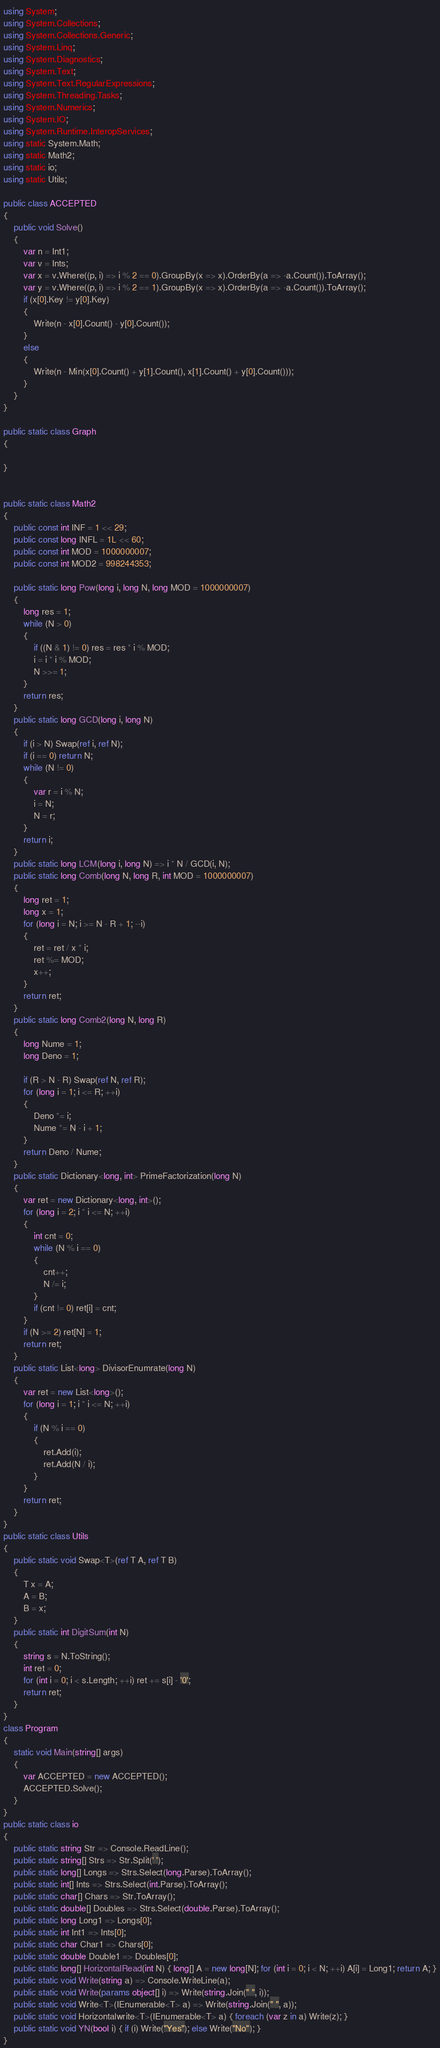Convert code to text. <code><loc_0><loc_0><loc_500><loc_500><_C#_>using System;
using System.Collections;
using System.Collections.Generic;
using System.Linq;
using System.Diagnostics;
using System.Text;
using System.Text.RegularExpressions;
using System.Threading.Tasks;
using System.Numerics;
using System.IO;
using System.Runtime.InteropServices;
using static System.Math;
using static Math2;
using static io;
using static Utils;

public class ACCEPTED
{
    public void Solve()
    {
        var n = Int1;
        var v = Ints;
        var x = v.Where((p, i) => i % 2 == 0).GroupBy(x => x).OrderBy(a => -a.Count()).ToArray();
        var y = v.Where((p, i) => i % 2 == 1).GroupBy(x => x).OrderBy(a => -a.Count()).ToArray();
        if (x[0].Key != y[0].Key)
        {
            Write(n - x[0].Count() - y[0].Count());
        }
        else
        {
            Write(n - Min(x[0].Count() + y[1].Count(), x[1].Count() + y[0].Count()));
        }
    }
}

public static class Graph
{

}


public static class Math2
{
    public const int INF = 1 << 29;
    public const long INFL = 1L << 60;
    public const int MOD = 1000000007;
    public const int MOD2 = 998244353;

    public static long Pow(long i, long N, long MOD = 1000000007)
    {
        long res = 1;
        while (N > 0)
        {
            if ((N & 1) != 0) res = res * i % MOD;
            i = i * i % MOD;
            N >>= 1;
        }
        return res;
    }
    public static long GCD(long i, long N)
    {
        if (i > N) Swap(ref i, ref N);
        if (i == 0) return N;
        while (N != 0)
        {
            var r = i % N;
            i = N;
            N = r;
        }
        return i;
    }
    public static long LCM(long i, long N) => i * N / GCD(i, N);
    public static long Comb(long N, long R, int MOD = 1000000007)
    {
        long ret = 1;
        long x = 1;
        for (long i = N; i >= N - R + 1; --i)
        {
            ret = ret / x * i;
            ret %= MOD;
            x++;
        }
        return ret;
    }
    public static long Comb2(long N, long R)
    {
        long Nume = 1;
        long Deno = 1;

        if (R > N - R) Swap(ref N, ref R);
        for (long i = 1; i <= R; ++i)
        {
            Deno *= i;
            Nume *= N - i + 1;
        }
        return Deno / Nume;
    }
    public static Dictionary<long, int> PrimeFactorization(long N)
    {
        var ret = new Dictionary<long, int>();
        for (long i = 2; i * i <= N; ++i)
        {
            int cnt = 0;
            while (N % i == 0)
            {
                cnt++;
                N /= i;
            }
            if (cnt != 0) ret[i] = cnt;
        }
        if (N >= 2) ret[N] = 1;
        return ret;
    }
    public static List<long> DivisorEnumrate(long N)
    {
        var ret = new List<long>();
        for (long i = 1; i * i <= N; ++i)
        {
            if (N % i == 0)
            {
                ret.Add(i);
                ret.Add(N / i);
            }
        }
        return ret;
    }
}
public static class Utils
{
    public static void Swap<T>(ref T A, ref T B)
    {
        T x = A;
        A = B;
        B = x;
    }
    public static int DigitSum(int N)
    {
        string s = N.ToString();
        int ret = 0;
        for (int i = 0; i < s.Length; ++i) ret += s[i] - '0';
        return ret;
    }
}
class Program
{
    static void Main(string[] args)
    {
        var ACCEPTED = new ACCEPTED();
        ACCEPTED.Solve();
    }
}
public static class io
{
    public static string Str => Console.ReadLine();
    public static string[] Strs => Str.Split(' ');
    public static long[] Longs => Strs.Select(long.Parse).ToArray();
    public static int[] Ints => Strs.Select(int.Parse).ToArray();
    public static char[] Chars => Str.ToArray();
    public static double[] Doubles => Strs.Select(double.Parse).ToArray();
    public static long Long1 => Longs[0];
    public static int Int1 => Ints[0];
    public static char Char1 => Chars[0];
    public static double Double1 => Doubles[0];
    public static long[] HorizontalRead(int N) { long[] A = new long[N]; for (int i = 0; i < N; ++i) A[i] = Long1; return A; }
    public static void Write(string a) => Console.WriteLine(a);
    public static void Write(params object[] i) => Write(string.Join(" ", i));
    public static void Write<T>(IEnumerable<T> a) => Write(string.Join(" ", a));
    public static void Horizontalwrite<T>(IEnumerable<T> a) { foreach (var z in a) Write(z); }
    public static void YN(bool i) { if (i) Write("Yes"); else Write("No"); }
}
</code> 